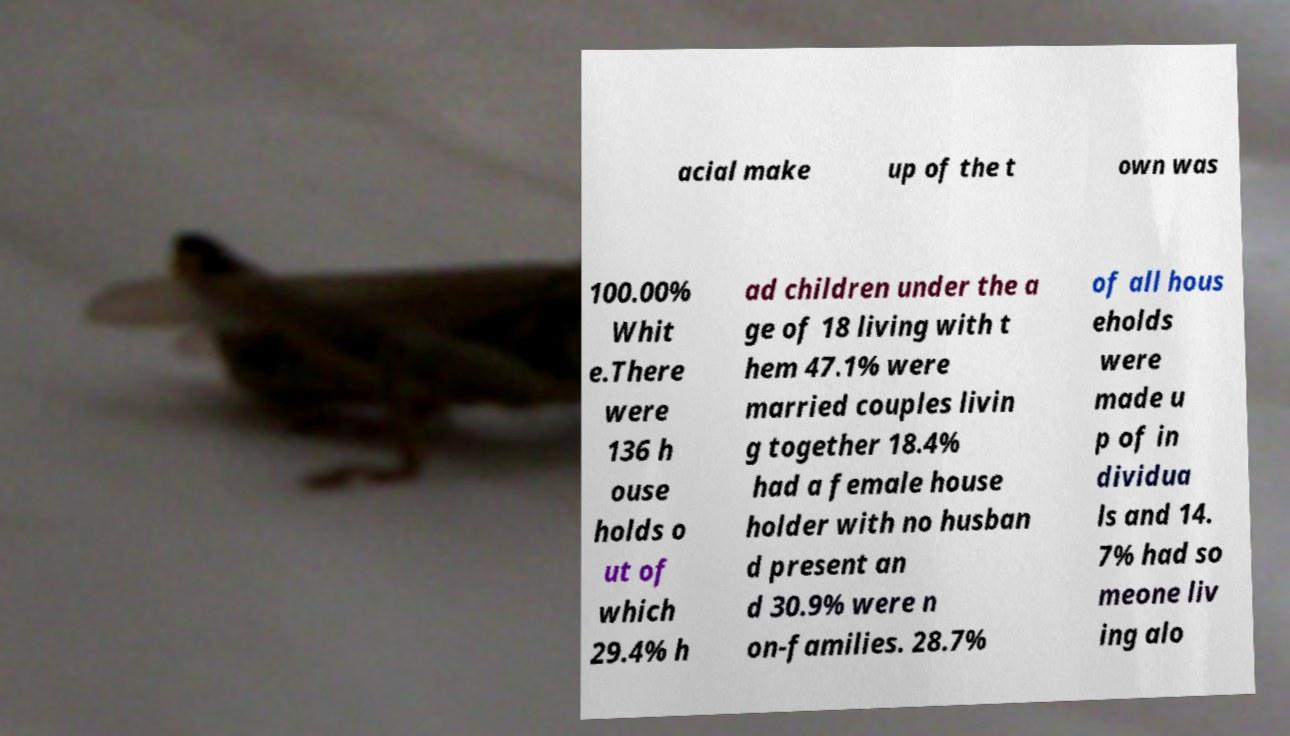I need the written content from this picture converted into text. Can you do that? acial make up of the t own was 100.00% Whit e.There were 136 h ouse holds o ut of which 29.4% h ad children under the a ge of 18 living with t hem 47.1% were married couples livin g together 18.4% had a female house holder with no husban d present an d 30.9% were n on-families. 28.7% of all hous eholds were made u p of in dividua ls and 14. 7% had so meone liv ing alo 